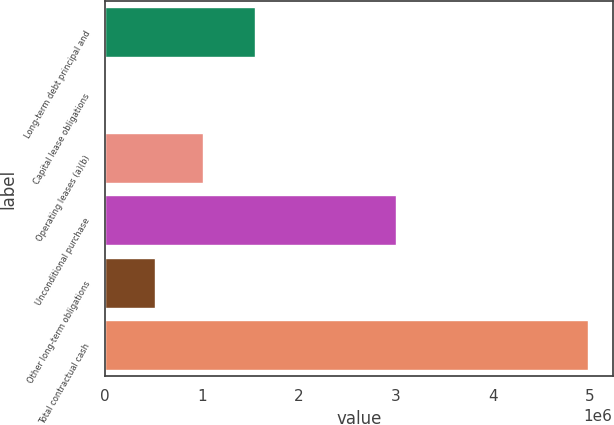Convert chart to OTSL. <chart><loc_0><loc_0><loc_500><loc_500><bar_chart><fcel>Long-term debt principal and<fcel>Capital lease obligations<fcel>Operating leases (a)(b)<fcel>Unconditional purchase<fcel>Other long-term obligations<fcel>Total contractual cash<nl><fcel>1.54874e+06<fcel>11463<fcel>1.00665e+06<fcel>3.00382e+06<fcel>509056<fcel>4.98739e+06<nl></chart> 